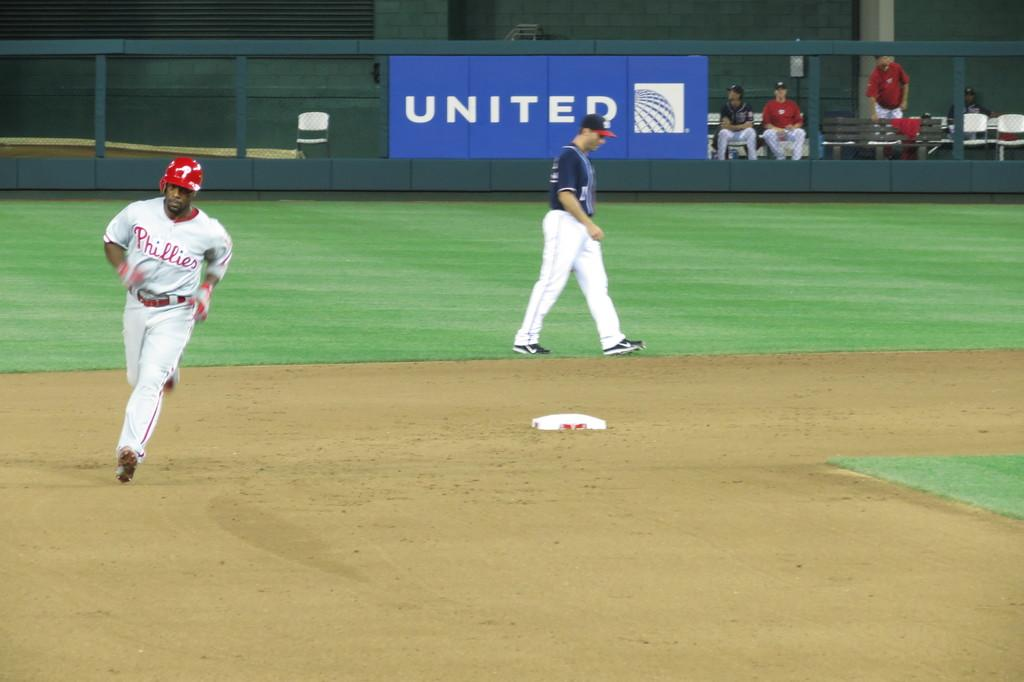<image>
Provide a brief description of the given image. a baseball game with a player from the Philadelphia phillies running the bases 